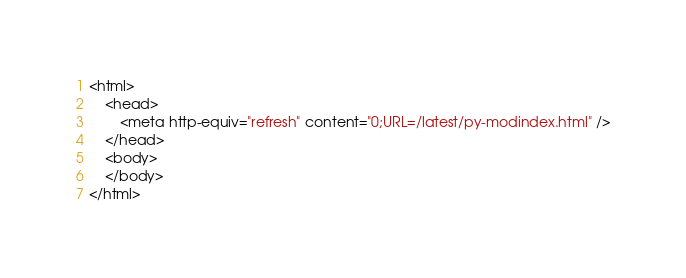Convert code to text. <code><loc_0><loc_0><loc_500><loc_500><_HTML_><html>
    <head>
        <meta http-equiv="refresh" content="0;URL=/latest/py-modindex.html" />
    </head>
    <body>
    </body>
</html>

</code> 